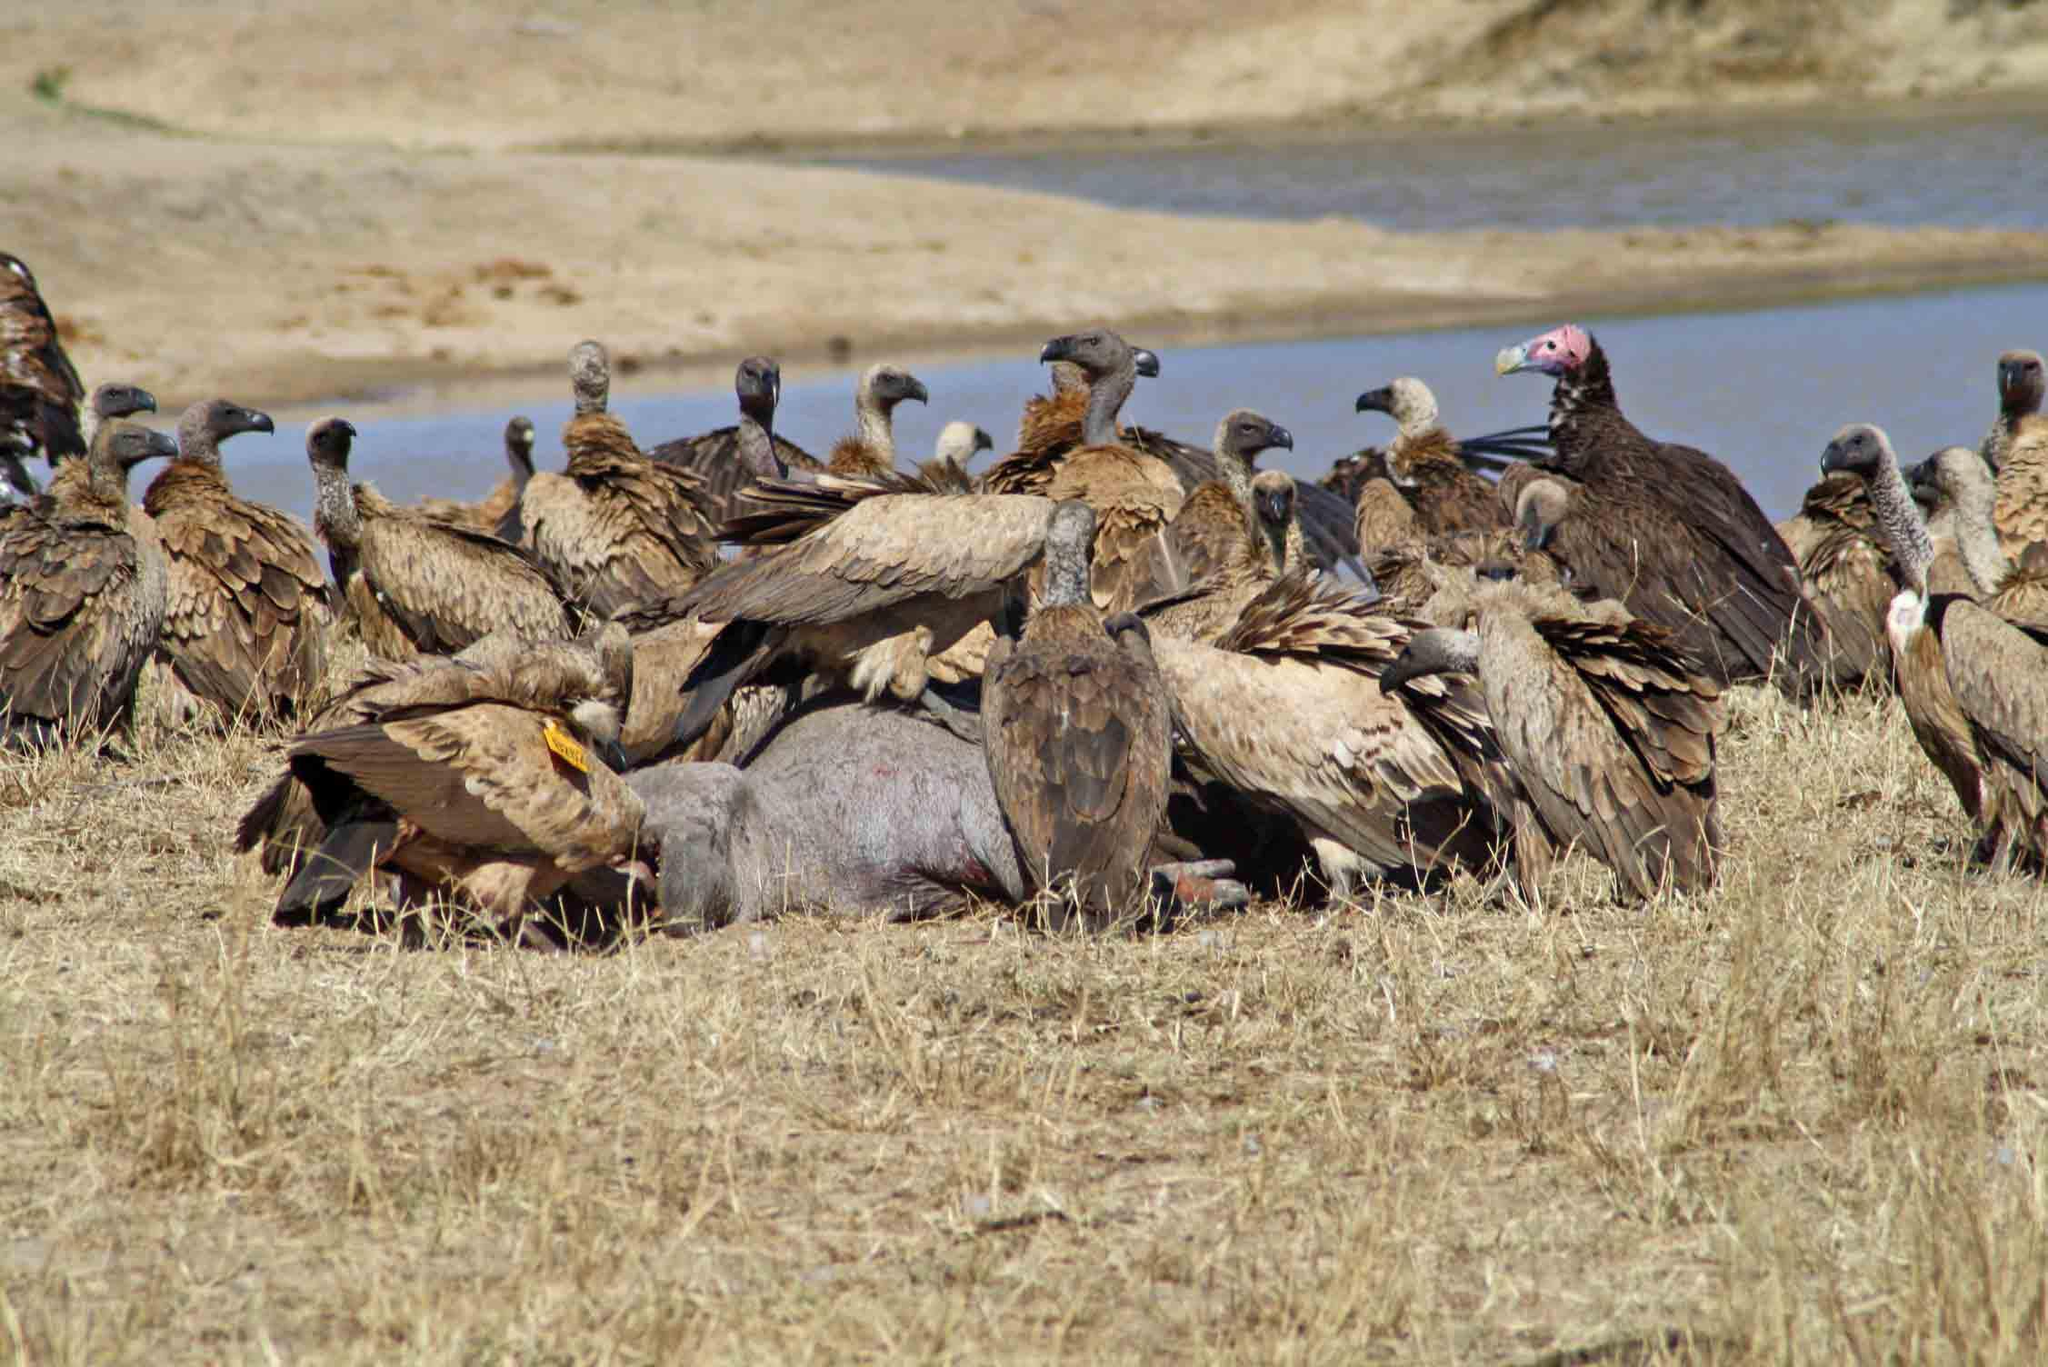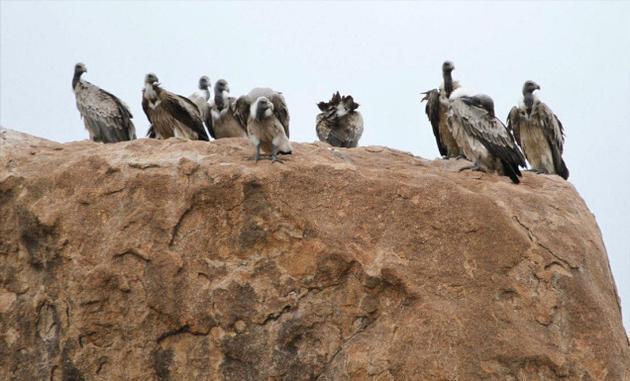The first image is the image on the left, the second image is the image on the right. For the images shown, is this caption "There is water in the image on the left." true? Answer yes or no. Yes. 